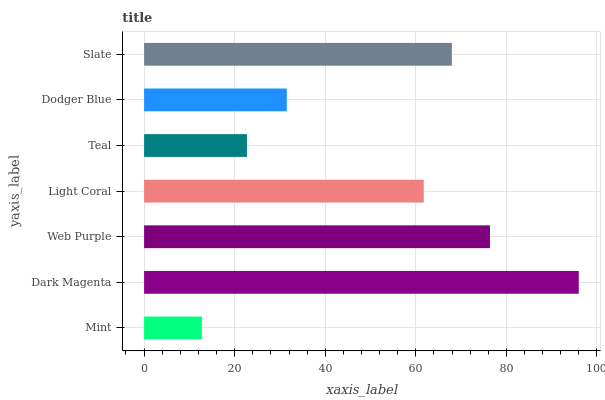Is Mint the minimum?
Answer yes or no. Yes. Is Dark Magenta the maximum?
Answer yes or no. Yes. Is Web Purple the minimum?
Answer yes or no. No. Is Web Purple the maximum?
Answer yes or no. No. Is Dark Magenta greater than Web Purple?
Answer yes or no. Yes. Is Web Purple less than Dark Magenta?
Answer yes or no. Yes. Is Web Purple greater than Dark Magenta?
Answer yes or no. No. Is Dark Magenta less than Web Purple?
Answer yes or no. No. Is Light Coral the high median?
Answer yes or no. Yes. Is Light Coral the low median?
Answer yes or no. Yes. Is Web Purple the high median?
Answer yes or no. No. Is Dodger Blue the low median?
Answer yes or no. No. 